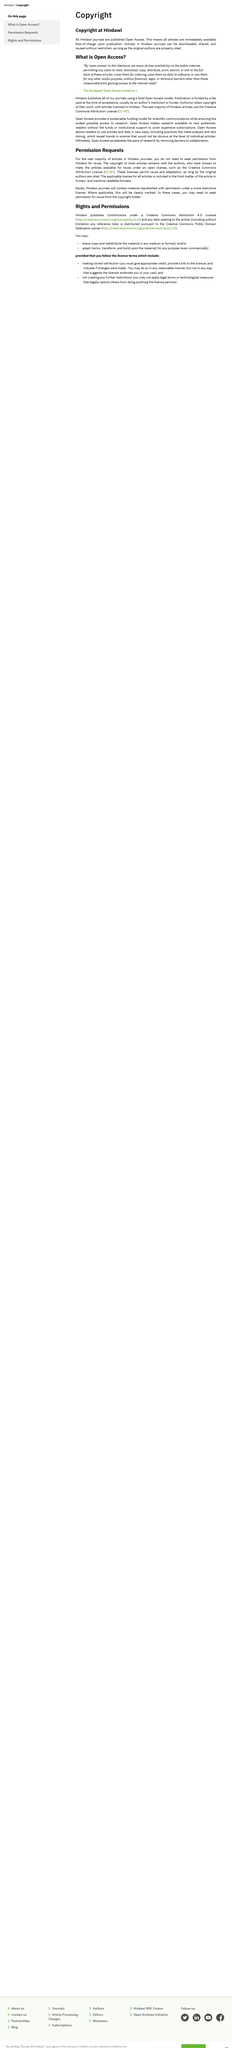Specify some key components in this picture. Yes, it is permissible to share and adapt Hindawi contributions. The Creative Commons Attribution License allows for the reuse and modification of content as long as the original authors are credited. Yes, there are multiple licenses used for articles in Hindawi journals. Open access allows research to progress at a faster pace by removing barriers to collaboration and access to information. Hindawi publishes articles under a Creative Commons Attribution 4.0 License. 